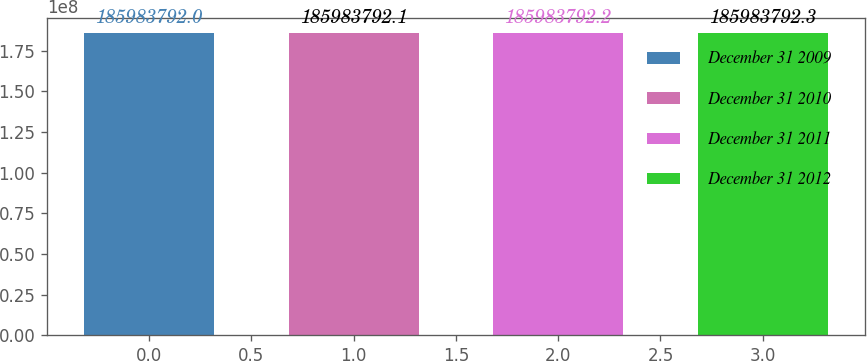Convert chart to OTSL. <chart><loc_0><loc_0><loc_500><loc_500><bar_chart><fcel>December 31 2009<fcel>December 31 2010<fcel>December 31 2011<fcel>December 31 2012<nl><fcel>1.85984e+08<fcel>1.85984e+08<fcel>1.85984e+08<fcel>1.85984e+08<nl></chart> 